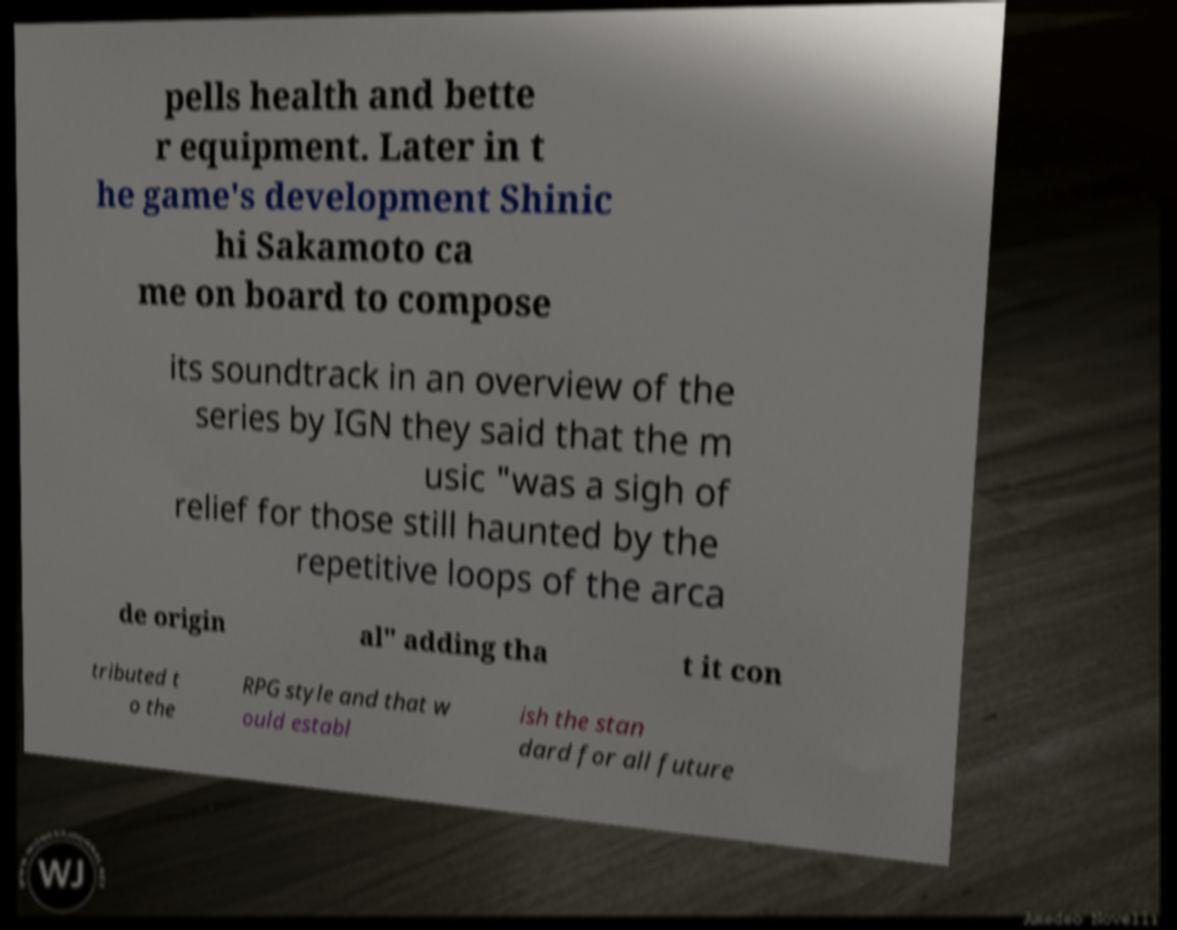Please read and relay the text visible in this image. What does it say? pells health and bette r equipment. Later in t he game's development Shinic hi Sakamoto ca me on board to compose its soundtrack in an overview of the series by IGN they said that the m usic "was a sigh of relief for those still haunted by the repetitive loops of the arca de origin al" adding tha t it con tributed t o the RPG style and that w ould establ ish the stan dard for all future 